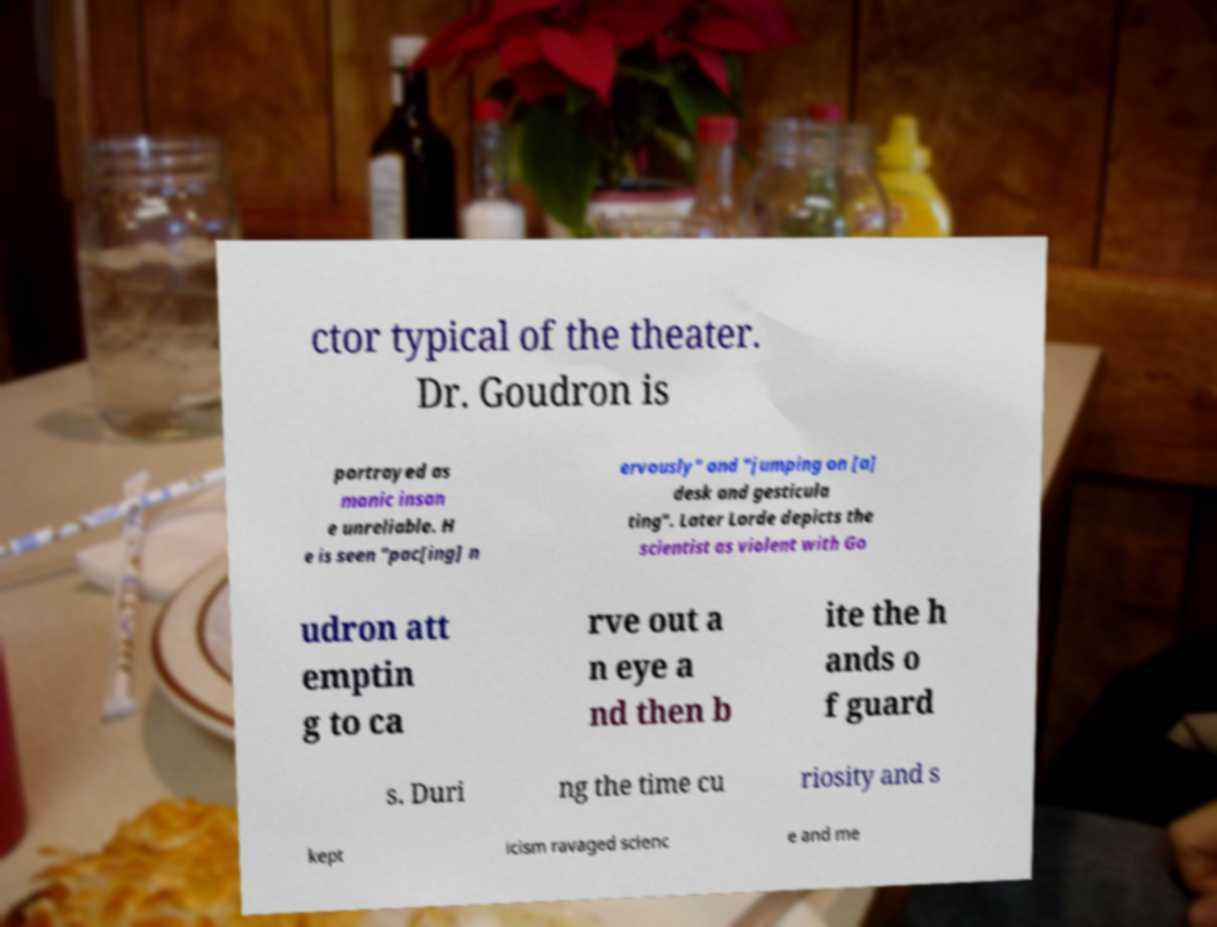I need the written content from this picture converted into text. Can you do that? ctor typical of the theater. Dr. Goudron is portrayed as manic insan e unreliable. H e is seen "pac[ing] n ervously" and "jumping on [a] desk and gesticula ting". Later Lorde depicts the scientist as violent with Go udron att emptin g to ca rve out a n eye a nd then b ite the h ands o f guard s. Duri ng the time cu riosity and s kept icism ravaged scienc e and me 